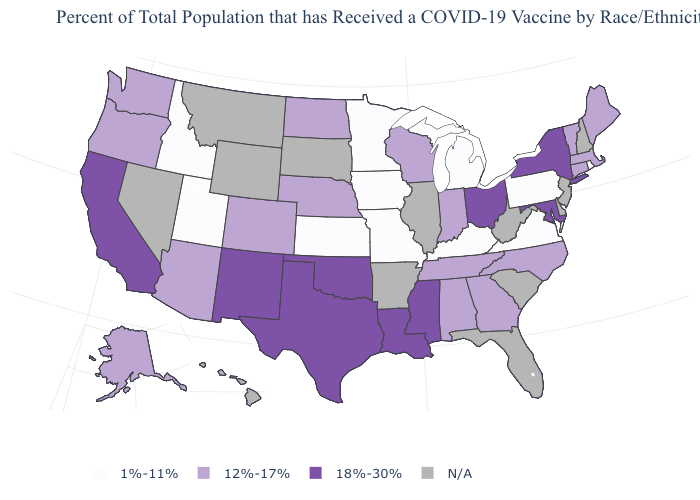What is the value of Vermont?
Answer briefly. 12%-17%. Name the states that have a value in the range 12%-17%?
Short answer required. Alabama, Alaska, Arizona, Colorado, Connecticut, Georgia, Indiana, Maine, Massachusetts, Nebraska, North Carolina, North Dakota, Oregon, Tennessee, Vermont, Washington, Wisconsin. Name the states that have a value in the range 12%-17%?
Quick response, please. Alabama, Alaska, Arizona, Colorado, Connecticut, Georgia, Indiana, Maine, Massachusetts, Nebraska, North Carolina, North Dakota, Oregon, Tennessee, Vermont, Washington, Wisconsin. Which states have the lowest value in the USA?
Be succinct. Idaho, Iowa, Kansas, Kentucky, Michigan, Minnesota, Missouri, Pennsylvania, Rhode Island, Utah, Virginia. Which states hav the highest value in the Northeast?
Keep it brief. New York. What is the value of Maine?
Give a very brief answer. 12%-17%. Name the states that have a value in the range 18%-30%?
Keep it brief. California, Louisiana, Maryland, Mississippi, New Mexico, New York, Ohio, Oklahoma, Texas. What is the value of Texas?
Answer briefly. 18%-30%. What is the highest value in states that border Oregon?
Give a very brief answer. 18%-30%. Which states hav the highest value in the South?
Write a very short answer. Louisiana, Maryland, Mississippi, Oklahoma, Texas. Name the states that have a value in the range 1%-11%?
Short answer required. Idaho, Iowa, Kansas, Kentucky, Michigan, Minnesota, Missouri, Pennsylvania, Rhode Island, Utah, Virginia. Does the first symbol in the legend represent the smallest category?
Concise answer only. Yes. How many symbols are there in the legend?
Write a very short answer. 4. 